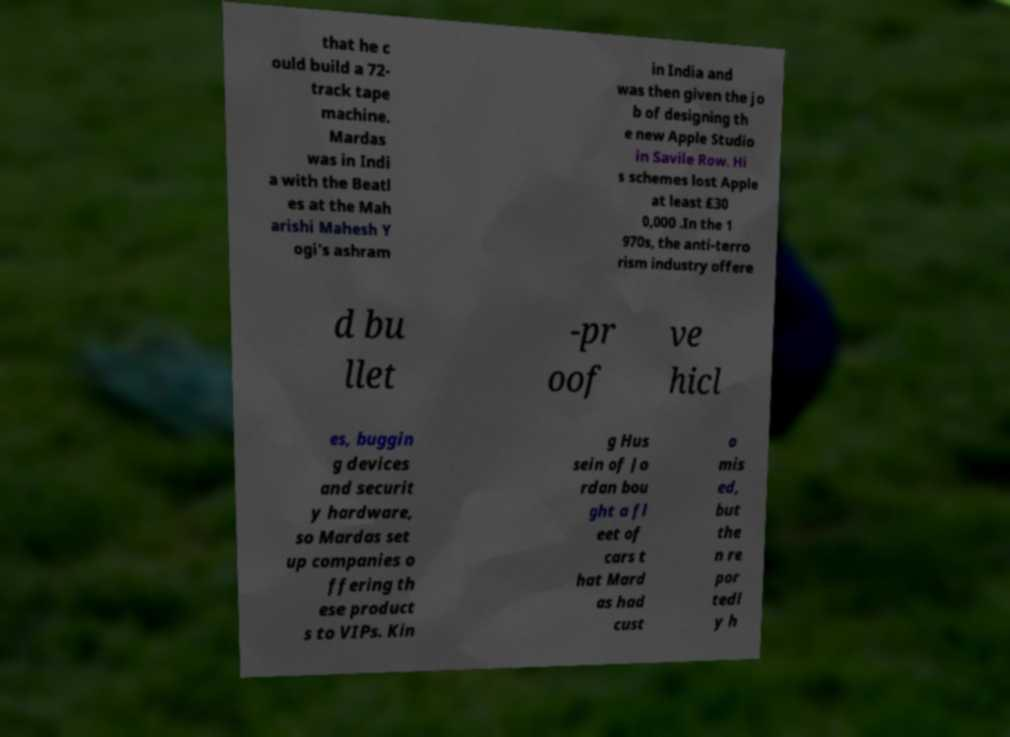There's text embedded in this image that I need extracted. Can you transcribe it verbatim? that he c ould build a 72- track tape machine. Mardas was in Indi a with the Beatl es at the Mah arishi Mahesh Y ogi's ashram in India and was then given the jo b of designing th e new Apple Studio in Savile Row. Hi s schemes lost Apple at least £30 0,000 .In the 1 970s, the anti-terro rism industry offere d bu llet -pr oof ve hicl es, buggin g devices and securit y hardware, so Mardas set up companies o ffering th ese product s to VIPs. Kin g Hus sein of Jo rdan bou ght a fl eet of cars t hat Mard as had cust o mis ed, but the n re por tedl y h 